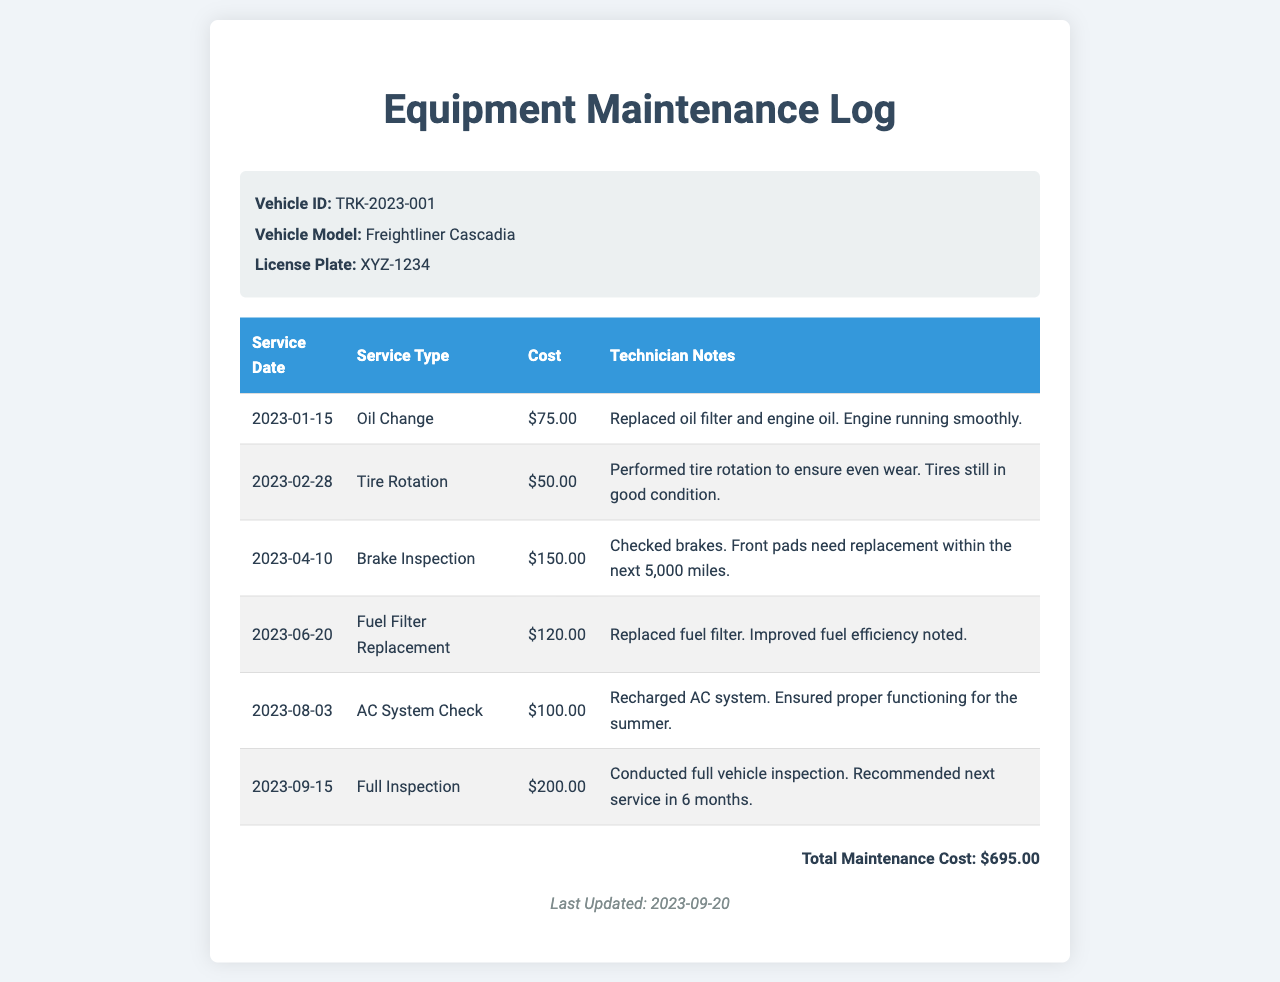what is the Vehicle ID? The Vehicle ID is a unique identifier for the vehicle, listed as TRK-2023-001 in the document.
Answer: TRK-2023-001 what is the total maintenance cost? The total maintenance cost is calculated by summing all service costs listed in the maintenance log, which totals $695.00.
Answer: $695.00 how many service types are recorded? The document lists six different service types performed on the vehicle, each shown in a separate row.
Answer: 6 what is the service date for the last inspection? The last inspection was conducted on September 15, 2023, as indicated in the service log.
Answer: 2023-09-15 which service had the highest cost? The service with the highest cost is the Full Inspection, which is priced at $200.00.
Answer: Full Inspection what was noted during the brake inspection? The technician noted that the front pads need replacement within the next 5,000 miles during the brake inspection performed on April 10, 2023.
Answer: Front pads need replacement when was the last update made to the maintenance log? The last update to the maintenance log is stated to have been made on September 20, 2023.
Answer: 2023-09-20 how much did the fuel filter replacement cost? The cost for the fuel filter replacement service is listed as $120.00.
Answer: $120.00 what was the technician's note for the AC system check? The technician's note states that the AC system was recharged and ensured proper functioning for the summer.
Answer: Recharged AC system 